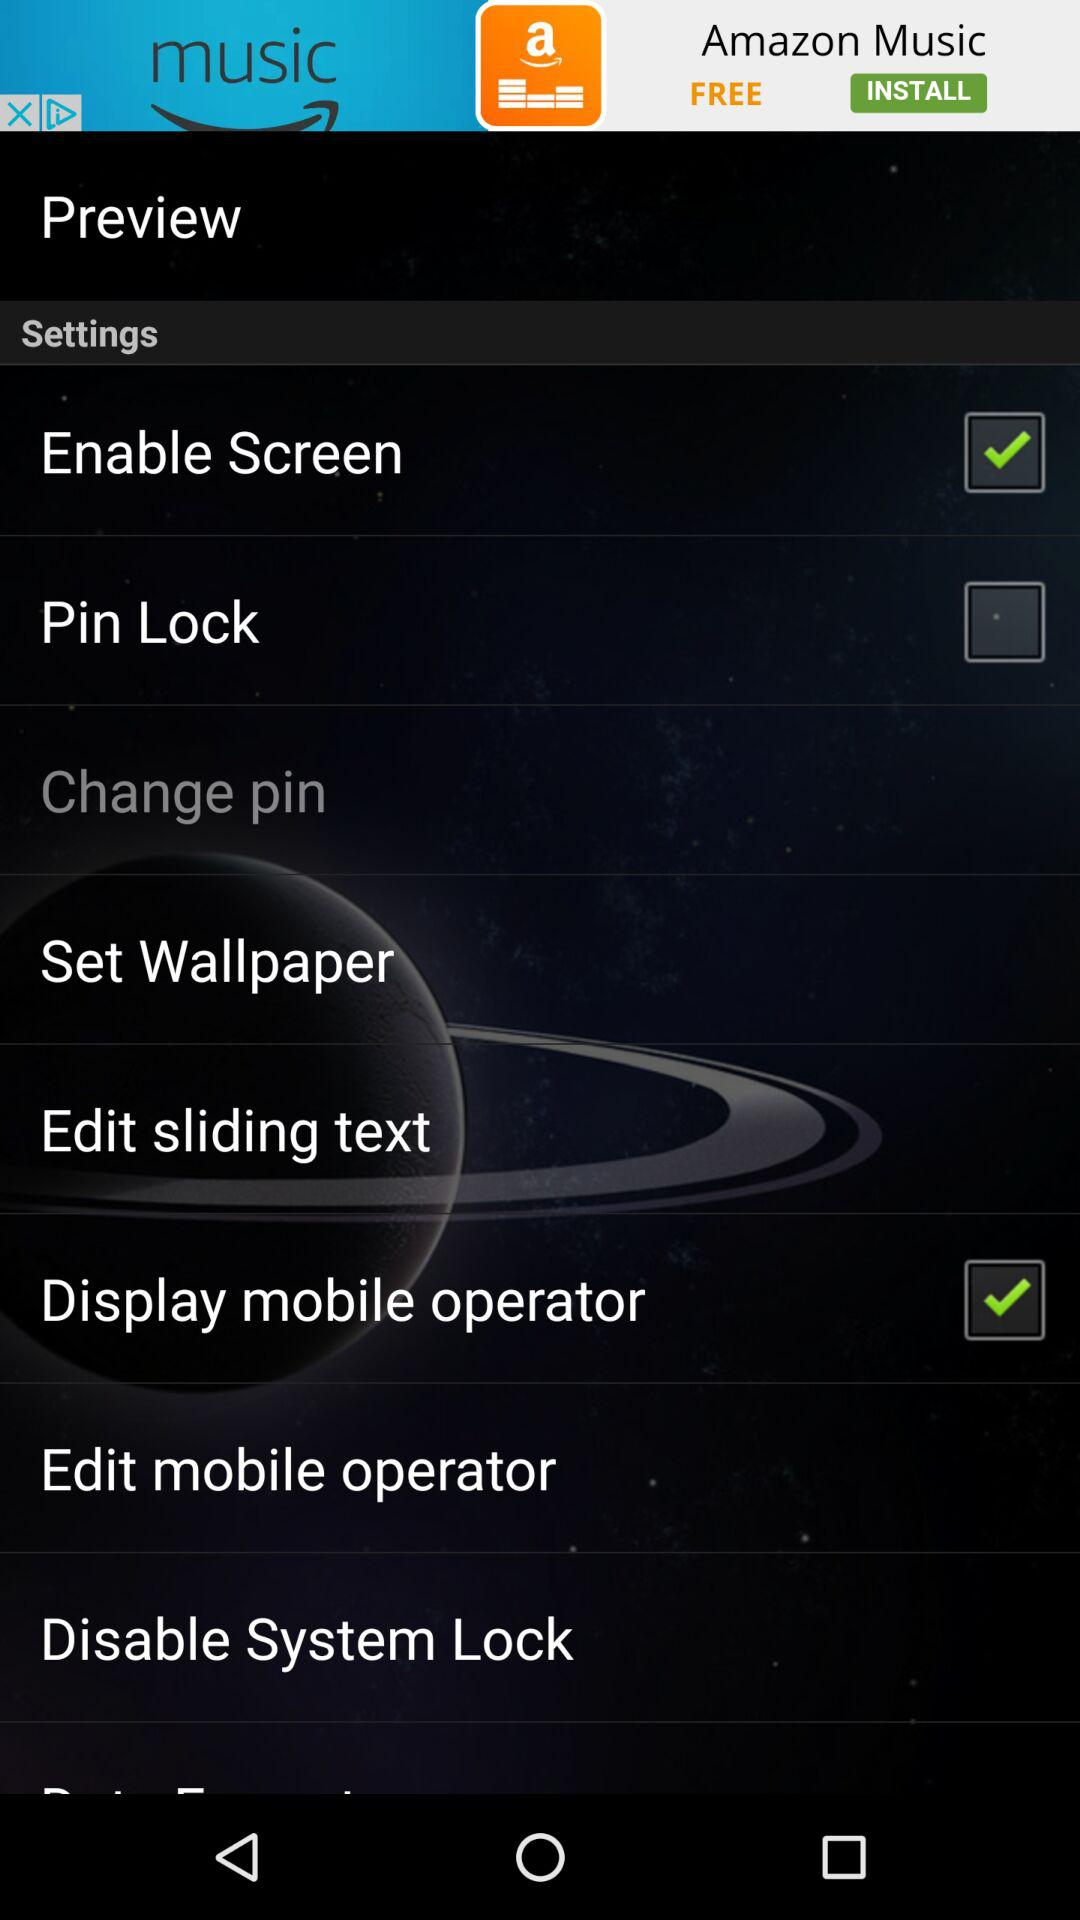What is the status of the display mobile alert? The status of the display mobile alert is on. 